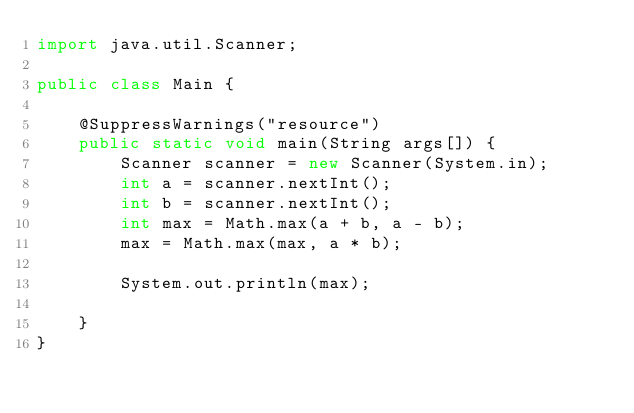<code> <loc_0><loc_0><loc_500><loc_500><_Java_>import java.util.Scanner;

public class Main {

	@SuppressWarnings("resource")
	public static void main(String args[]) {
		Scanner scanner = new Scanner(System.in);
		int a = scanner.nextInt();
		int b = scanner.nextInt();
		int max = Math.max(a + b, a - b);
		max = Math.max(max, a * b);

		System.out.println(max);

	}
}
</code> 